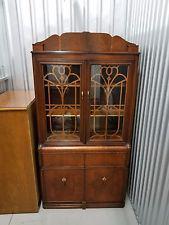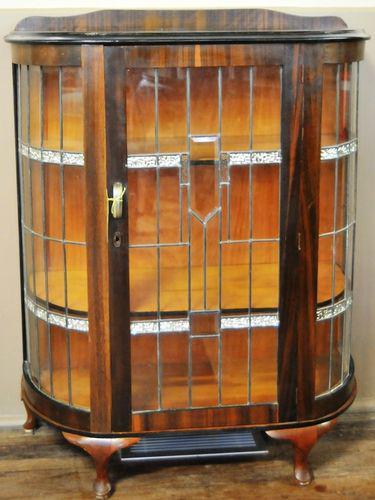The first image is the image on the left, the second image is the image on the right. For the images shown, is this caption "Right image features a cabinet with slender feet instead of wedge feet." true? Answer yes or no. Yes. The first image is the image on the left, the second image is the image on the right. Examine the images to the left and right. Is the description "One wooden cabinet on tall legs has a center rectangular glass panel on the front." accurate? Answer yes or no. No. 